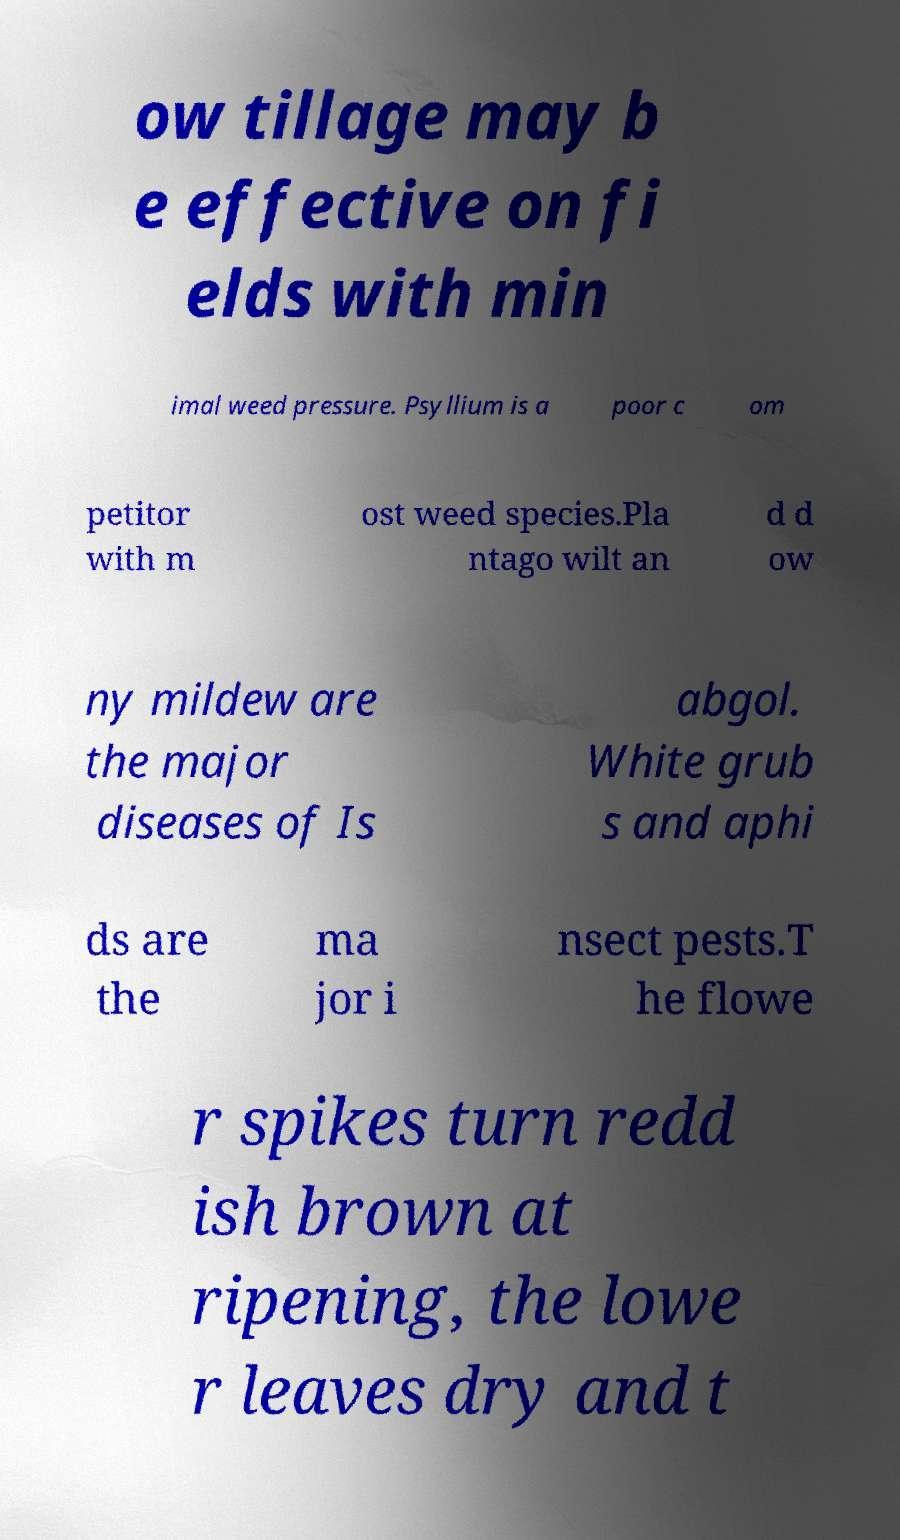Can you read and provide the text displayed in the image?This photo seems to have some interesting text. Can you extract and type it out for me? ow tillage may b e effective on fi elds with min imal weed pressure. Psyllium is a poor c om petitor with m ost weed species.Pla ntago wilt an d d ow ny mildew are the major diseases of Is abgol. White grub s and aphi ds are the ma jor i nsect pests.T he flowe r spikes turn redd ish brown at ripening, the lowe r leaves dry and t 